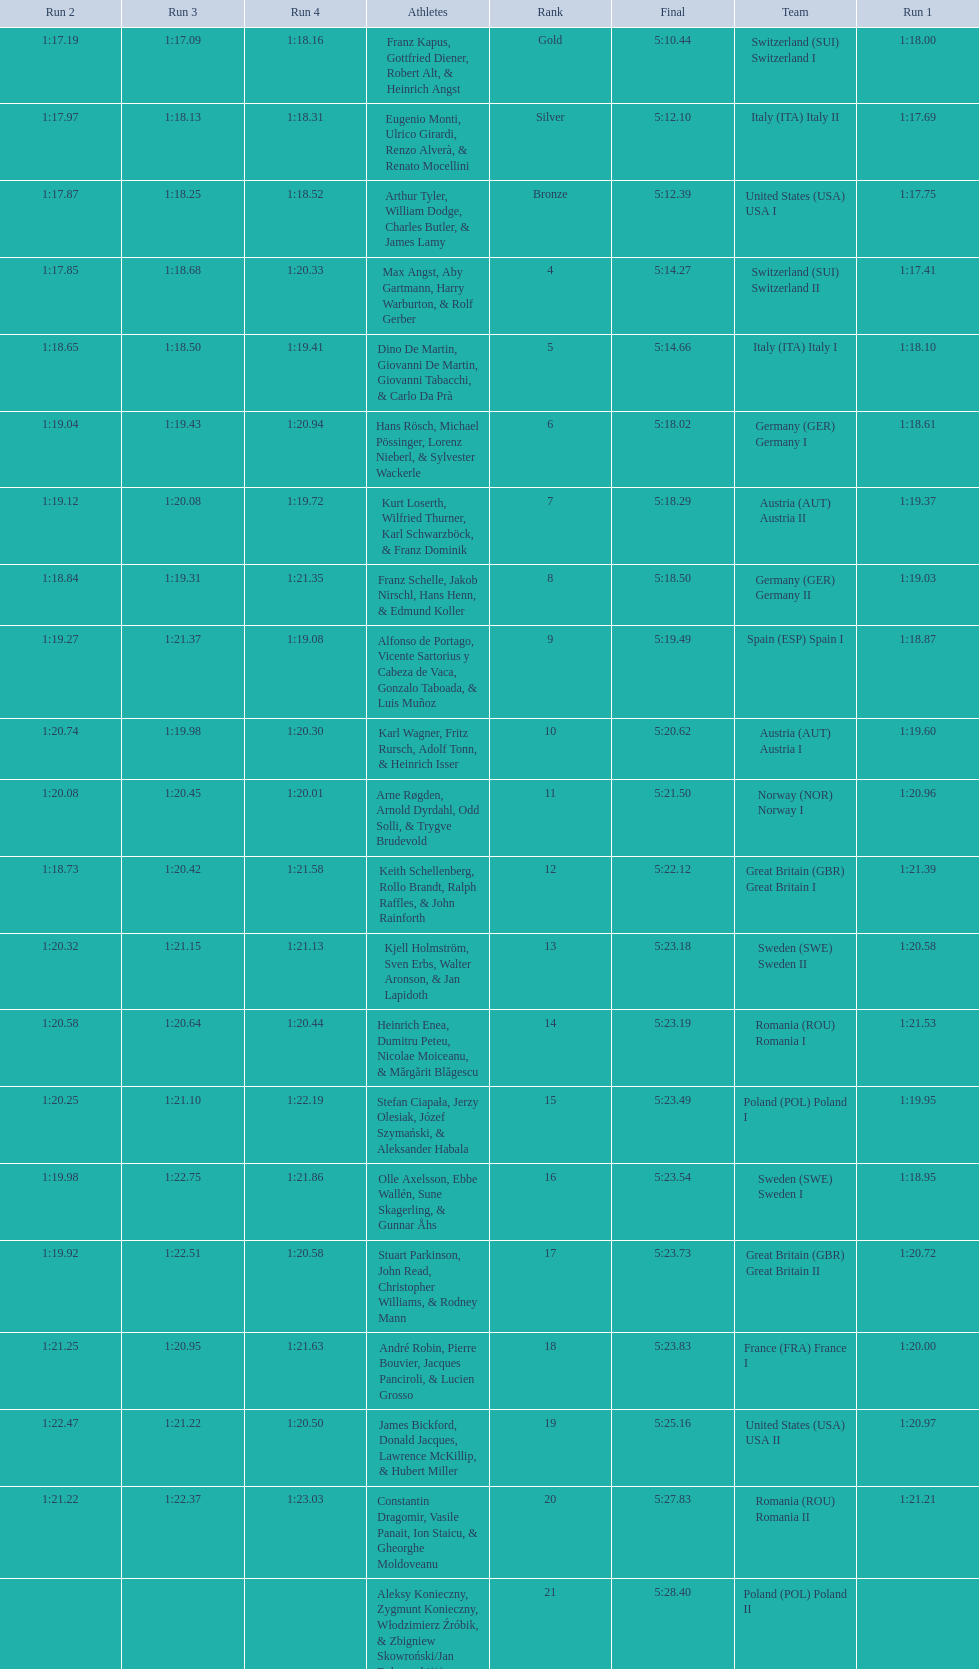What team came in second to last place? Romania. 